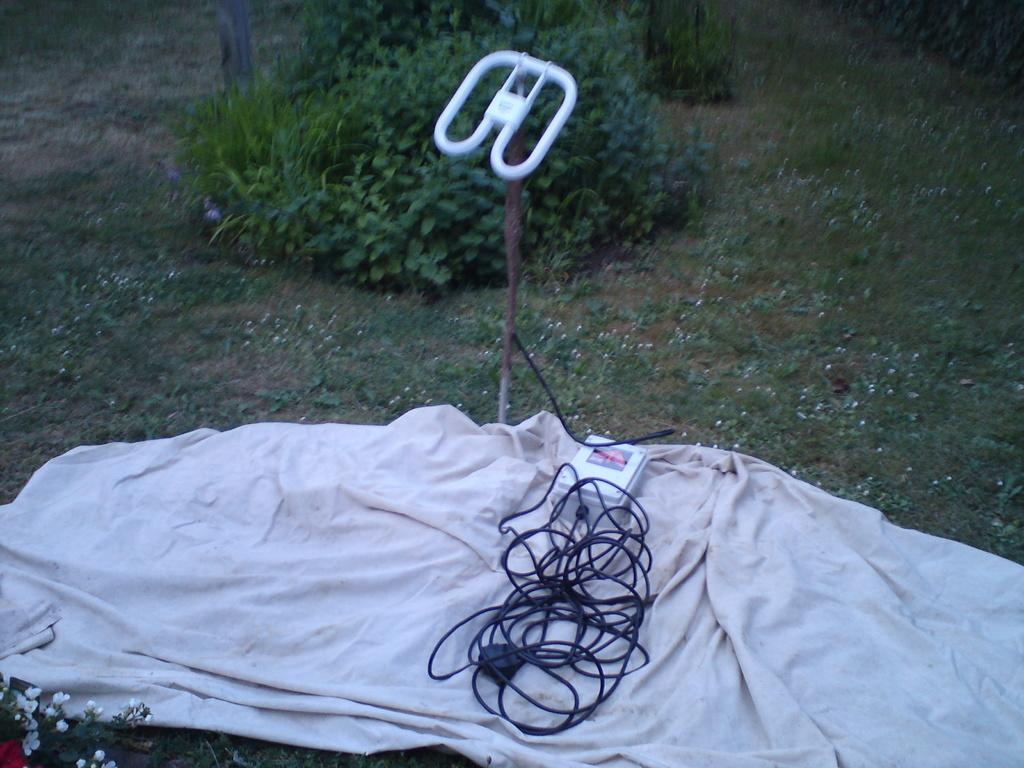What type of living organisms can be seen in the image? Plants and flowers are visible in the image. What is the cloth used for in the image? The cloth is on the ground, possibly for decoration or to protect the ground. Can you describe the electrical setup in the image? A wire is connected to an electric box in the image. What is the wooden stick used for in the image? The wooden stick's purpose is not clear from the image, but it could be a tool or decoration. What type of terrain is visible in the image? Grass is present in the image, suggesting a grassy area. How does the dock help the plants in the image? There is no dock present in the image, so it cannot help the plants. Can you describe the digestion process of the flowers in the image? Flowers do not have a digestion process, as they are not living organisms capable of digestion. 